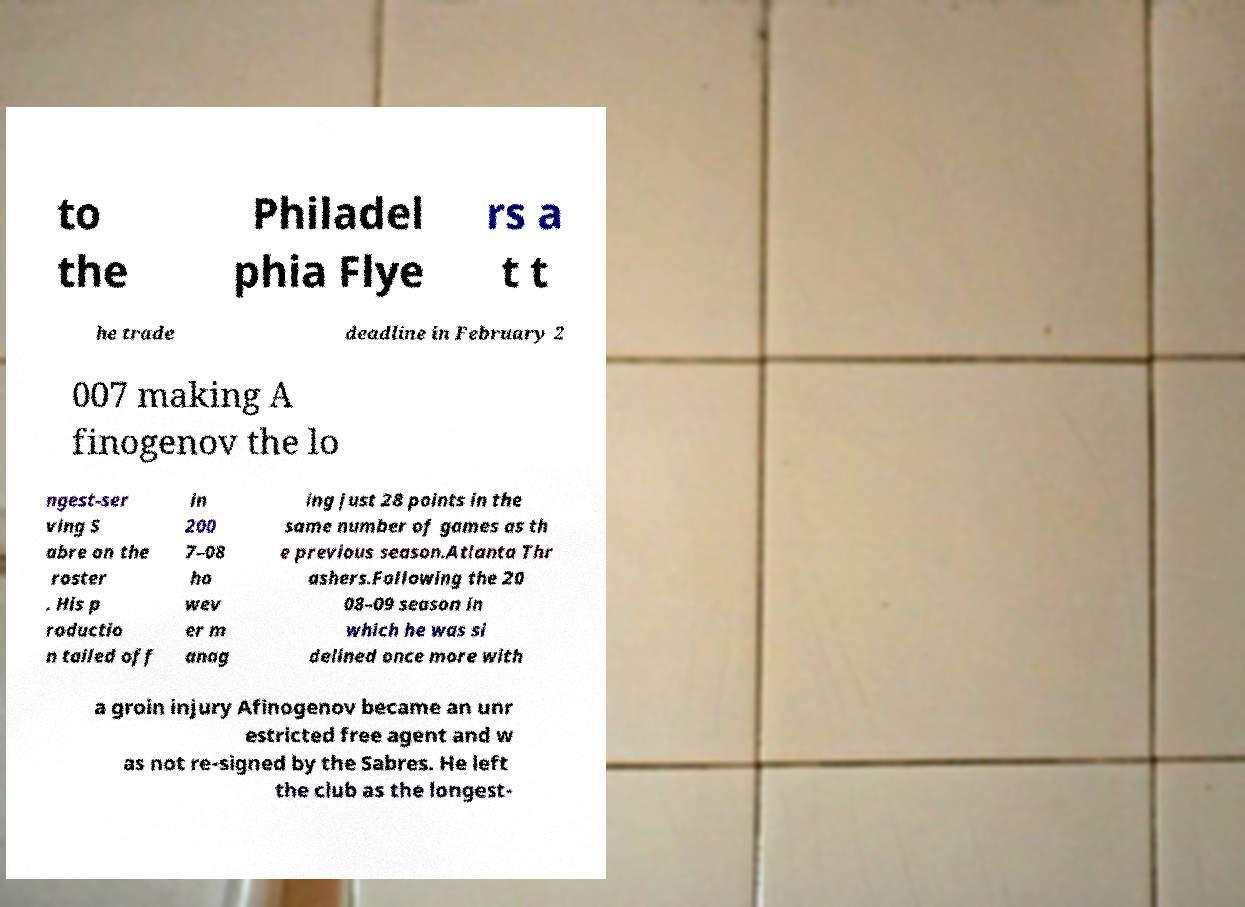I need the written content from this picture converted into text. Can you do that? to the Philadel phia Flye rs a t t he trade deadline in February 2 007 making A finogenov the lo ngest-ser ving S abre on the roster . His p roductio n tailed off in 200 7–08 ho wev er m anag ing just 28 points in the same number of games as th e previous season.Atlanta Thr ashers.Following the 20 08–09 season in which he was si delined once more with a groin injury Afinogenov became an unr estricted free agent and w as not re-signed by the Sabres. He left the club as the longest- 